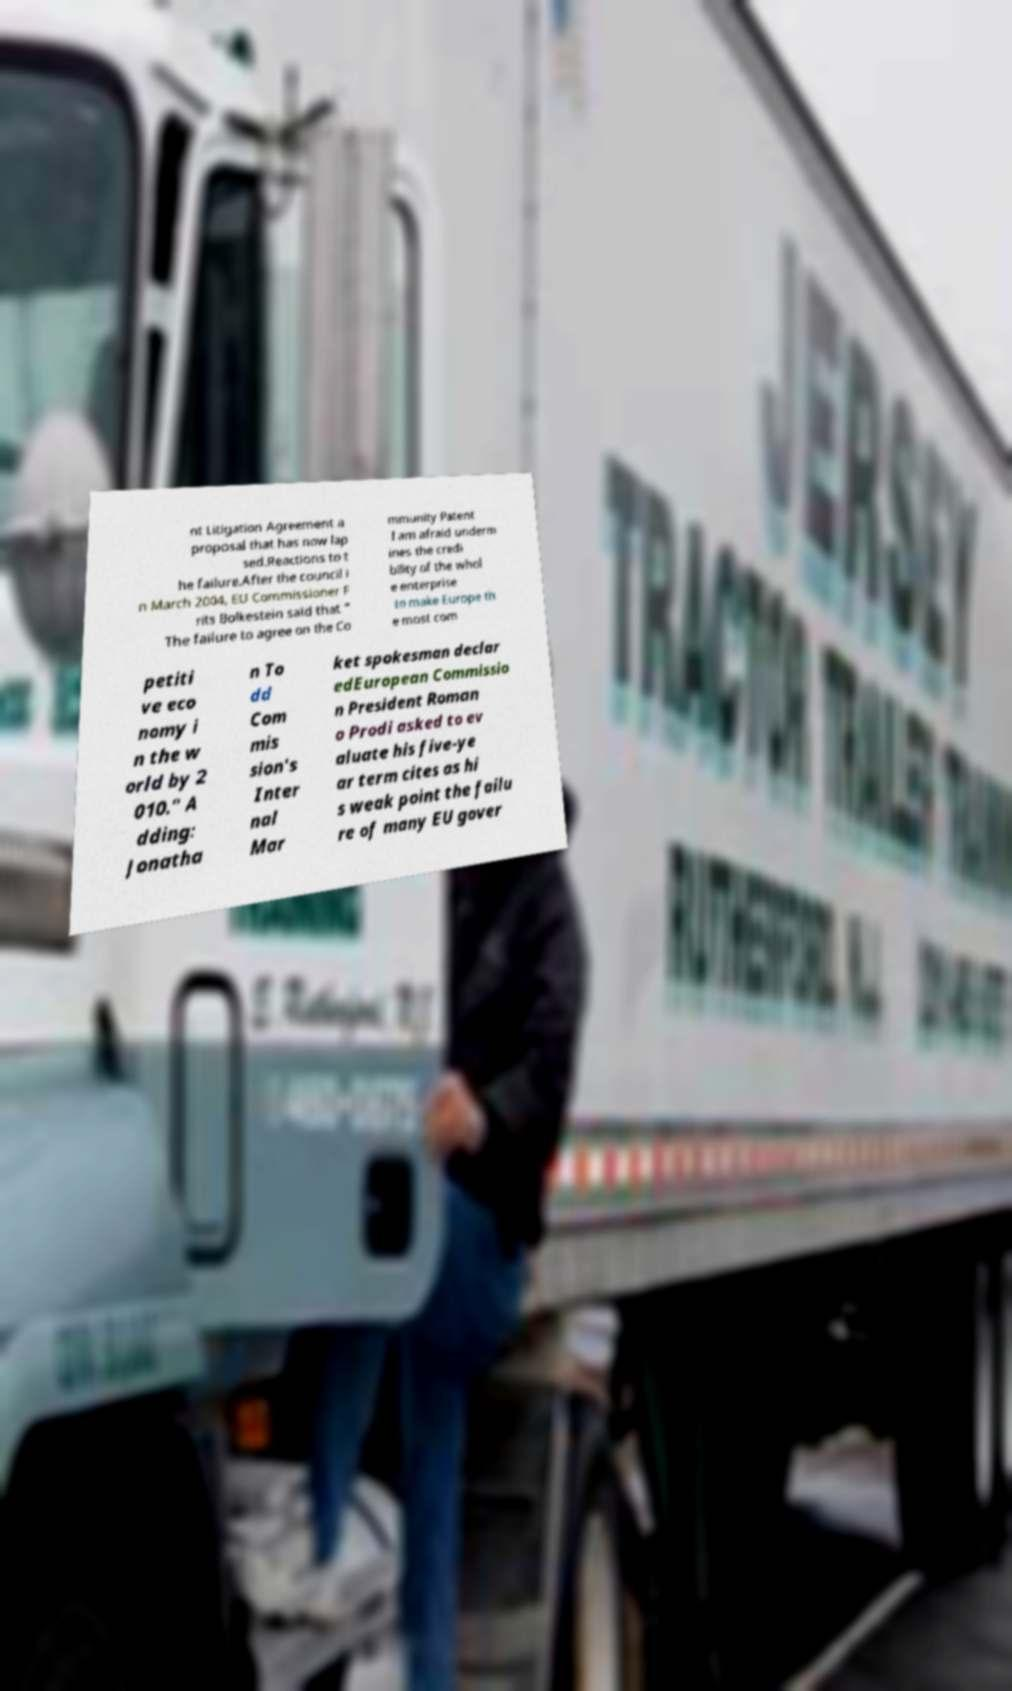Please identify and transcribe the text found in this image. nt Litigation Agreement a proposal that has now lap sed.Reactions to t he failure.After the council i n March 2004, EU Commissioner F rits Bolkestein said that " The failure to agree on the Co mmunity Patent I am afraid underm ines the credi bility of the whol e enterprise to make Europe th e most com petiti ve eco nomy i n the w orld by 2 010." A dding: Jonatha n To dd Com mis sion's Inter nal Mar ket spokesman declar edEuropean Commissio n President Roman o Prodi asked to ev aluate his five-ye ar term cites as hi s weak point the failu re of many EU gover 